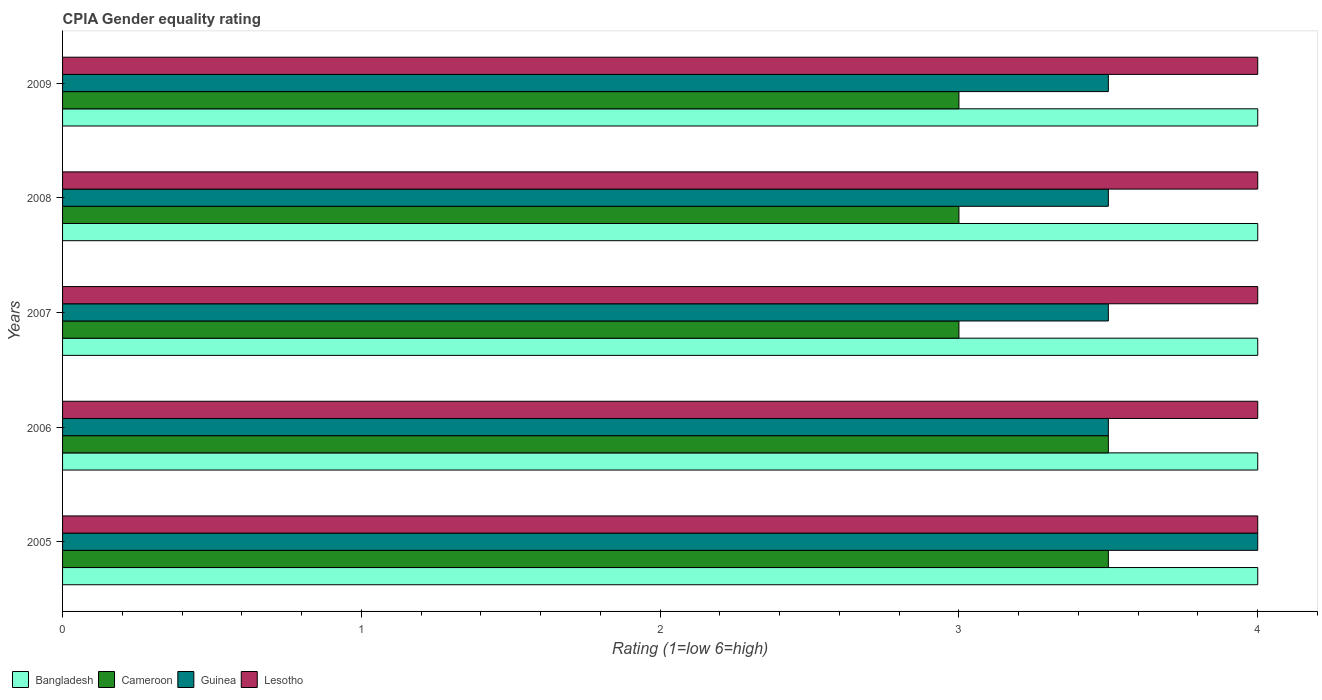Are the number of bars per tick equal to the number of legend labels?
Your answer should be very brief. Yes. Are the number of bars on each tick of the Y-axis equal?
Provide a short and direct response. Yes. How many bars are there on the 4th tick from the top?
Make the answer very short. 4. In how many cases, is the number of bars for a given year not equal to the number of legend labels?
Your response must be concise. 0. What is the CPIA rating in Lesotho in 2009?
Ensure brevity in your answer.  4. What is the total CPIA rating in Guinea in the graph?
Provide a succinct answer. 18. What is the difference between the CPIA rating in Bangladesh in 2006 and that in 2009?
Offer a very short reply. 0. What is the difference between the CPIA rating in Cameroon in 2008 and the CPIA rating in Bangladesh in 2007?
Your response must be concise. -1. What is the average CPIA rating in Bangladesh per year?
Your response must be concise. 4. In how many years, is the CPIA rating in Lesotho greater than 2 ?
Keep it short and to the point. 5. What is the ratio of the CPIA rating in Guinea in 2005 to that in 2006?
Give a very brief answer. 1.14. What is the difference between the highest and the second highest CPIA rating in Lesotho?
Provide a short and direct response. 0. What is the difference between the highest and the lowest CPIA rating in Bangladesh?
Give a very brief answer. 0. In how many years, is the CPIA rating in Bangladesh greater than the average CPIA rating in Bangladesh taken over all years?
Make the answer very short. 0. Is the sum of the CPIA rating in Cameroon in 2006 and 2009 greater than the maximum CPIA rating in Lesotho across all years?
Ensure brevity in your answer.  Yes. What does the 1st bar from the top in 2009 represents?
Keep it short and to the point. Lesotho. What does the 4th bar from the bottom in 2008 represents?
Make the answer very short. Lesotho. Are all the bars in the graph horizontal?
Make the answer very short. Yes. What is the difference between two consecutive major ticks on the X-axis?
Make the answer very short. 1. Are the values on the major ticks of X-axis written in scientific E-notation?
Your response must be concise. No. Does the graph contain any zero values?
Make the answer very short. No. Does the graph contain grids?
Offer a terse response. No. What is the title of the graph?
Offer a very short reply. CPIA Gender equality rating. What is the label or title of the X-axis?
Keep it short and to the point. Rating (1=low 6=high). What is the label or title of the Y-axis?
Keep it short and to the point. Years. What is the Rating (1=low 6=high) of Bangladesh in 2005?
Ensure brevity in your answer.  4. What is the Rating (1=low 6=high) in Guinea in 2005?
Your response must be concise. 4. What is the Rating (1=low 6=high) of Lesotho in 2005?
Your answer should be very brief. 4. What is the Rating (1=low 6=high) of Cameroon in 2006?
Make the answer very short. 3.5. What is the Rating (1=low 6=high) of Guinea in 2006?
Your response must be concise. 3.5. What is the Rating (1=low 6=high) of Lesotho in 2006?
Provide a short and direct response. 4. What is the Rating (1=low 6=high) of Guinea in 2007?
Provide a short and direct response. 3.5. What is the Rating (1=low 6=high) of Guinea in 2008?
Provide a short and direct response. 3.5. What is the Rating (1=low 6=high) of Bangladesh in 2009?
Keep it short and to the point. 4. What is the Rating (1=low 6=high) of Cameroon in 2009?
Make the answer very short. 3. Across all years, what is the maximum Rating (1=low 6=high) in Bangladesh?
Give a very brief answer. 4. Across all years, what is the maximum Rating (1=low 6=high) in Guinea?
Provide a succinct answer. 4. Across all years, what is the minimum Rating (1=low 6=high) in Guinea?
Give a very brief answer. 3.5. What is the total Rating (1=low 6=high) in Cameroon in the graph?
Your answer should be compact. 16. What is the total Rating (1=low 6=high) in Guinea in the graph?
Your answer should be very brief. 18. What is the difference between the Rating (1=low 6=high) of Bangladesh in 2005 and that in 2006?
Your response must be concise. 0. What is the difference between the Rating (1=low 6=high) of Guinea in 2005 and that in 2006?
Provide a succinct answer. 0.5. What is the difference between the Rating (1=low 6=high) of Lesotho in 2005 and that in 2006?
Offer a terse response. 0. What is the difference between the Rating (1=low 6=high) in Guinea in 2005 and that in 2007?
Give a very brief answer. 0.5. What is the difference between the Rating (1=low 6=high) in Bangladesh in 2005 and that in 2008?
Give a very brief answer. 0. What is the difference between the Rating (1=low 6=high) in Cameroon in 2005 and that in 2008?
Your answer should be very brief. 0.5. What is the difference between the Rating (1=low 6=high) of Guinea in 2005 and that in 2008?
Your answer should be very brief. 0.5. What is the difference between the Rating (1=low 6=high) in Lesotho in 2005 and that in 2008?
Offer a terse response. 0. What is the difference between the Rating (1=low 6=high) in Bangladesh in 2005 and that in 2009?
Offer a terse response. 0. What is the difference between the Rating (1=low 6=high) of Cameroon in 2005 and that in 2009?
Offer a very short reply. 0.5. What is the difference between the Rating (1=low 6=high) in Guinea in 2005 and that in 2009?
Keep it short and to the point. 0.5. What is the difference between the Rating (1=low 6=high) in Bangladesh in 2006 and that in 2007?
Make the answer very short. 0. What is the difference between the Rating (1=low 6=high) of Guinea in 2006 and that in 2007?
Your answer should be compact. 0. What is the difference between the Rating (1=low 6=high) in Lesotho in 2006 and that in 2008?
Ensure brevity in your answer.  0. What is the difference between the Rating (1=low 6=high) in Cameroon in 2006 and that in 2009?
Provide a short and direct response. 0.5. What is the difference between the Rating (1=low 6=high) in Guinea in 2006 and that in 2009?
Your answer should be compact. 0. What is the difference between the Rating (1=low 6=high) in Lesotho in 2007 and that in 2008?
Make the answer very short. 0. What is the difference between the Rating (1=low 6=high) in Lesotho in 2007 and that in 2009?
Provide a succinct answer. 0. What is the difference between the Rating (1=low 6=high) in Bangladesh in 2008 and that in 2009?
Keep it short and to the point. 0. What is the difference between the Rating (1=low 6=high) in Bangladesh in 2005 and the Rating (1=low 6=high) in Guinea in 2006?
Your answer should be compact. 0.5. What is the difference between the Rating (1=low 6=high) in Bangladesh in 2005 and the Rating (1=low 6=high) in Lesotho in 2006?
Offer a very short reply. 0. What is the difference between the Rating (1=low 6=high) of Cameroon in 2005 and the Rating (1=low 6=high) of Lesotho in 2006?
Keep it short and to the point. -0.5. What is the difference between the Rating (1=low 6=high) of Guinea in 2005 and the Rating (1=low 6=high) of Lesotho in 2006?
Your answer should be very brief. 0. What is the difference between the Rating (1=low 6=high) in Bangladesh in 2005 and the Rating (1=low 6=high) in Lesotho in 2007?
Provide a short and direct response. 0. What is the difference between the Rating (1=low 6=high) in Guinea in 2005 and the Rating (1=low 6=high) in Lesotho in 2007?
Keep it short and to the point. 0. What is the difference between the Rating (1=low 6=high) of Bangladesh in 2005 and the Rating (1=low 6=high) of Cameroon in 2008?
Keep it short and to the point. 1. What is the difference between the Rating (1=low 6=high) of Bangladesh in 2005 and the Rating (1=low 6=high) of Lesotho in 2008?
Your answer should be compact. 0. What is the difference between the Rating (1=low 6=high) of Cameroon in 2005 and the Rating (1=low 6=high) of Lesotho in 2008?
Offer a terse response. -0.5. What is the difference between the Rating (1=low 6=high) of Guinea in 2005 and the Rating (1=low 6=high) of Lesotho in 2008?
Ensure brevity in your answer.  0. What is the difference between the Rating (1=low 6=high) of Bangladesh in 2005 and the Rating (1=low 6=high) of Lesotho in 2009?
Your answer should be compact. 0. What is the difference between the Rating (1=low 6=high) of Cameroon in 2005 and the Rating (1=low 6=high) of Guinea in 2009?
Offer a terse response. 0. What is the difference between the Rating (1=low 6=high) in Bangladesh in 2006 and the Rating (1=low 6=high) in Cameroon in 2007?
Provide a short and direct response. 1. What is the difference between the Rating (1=low 6=high) of Cameroon in 2006 and the Rating (1=low 6=high) of Guinea in 2007?
Give a very brief answer. 0. What is the difference between the Rating (1=low 6=high) of Guinea in 2006 and the Rating (1=low 6=high) of Lesotho in 2007?
Ensure brevity in your answer.  -0.5. What is the difference between the Rating (1=low 6=high) of Bangladesh in 2006 and the Rating (1=low 6=high) of Guinea in 2008?
Your answer should be compact. 0.5. What is the difference between the Rating (1=low 6=high) in Bangladesh in 2006 and the Rating (1=low 6=high) in Lesotho in 2008?
Provide a short and direct response. 0. What is the difference between the Rating (1=low 6=high) of Cameroon in 2006 and the Rating (1=low 6=high) of Lesotho in 2008?
Ensure brevity in your answer.  -0.5. What is the difference between the Rating (1=low 6=high) in Bangladesh in 2006 and the Rating (1=low 6=high) in Guinea in 2009?
Offer a very short reply. 0.5. What is the difference between the Rating (1=low 6=high) in Cameroon in 2006 and the Rating (1=low 6=high) in Guinea in 2009?
Give a very brief answer. 0. What is the difference between the Rating (1=low 6=high) of Cameroon in 2006 and the Rating (1=low 6=high) of Lesotho in 2009?
Keep it short and to the point. -0.5. What is the difference between the Rating (1=low 6=high) in Bangladesh in 2007 and the Rating (1=low 6=high) in Guinea in 2008?
Keep it short and to the point. 0.5. What is the difference between the Rating (1=low 6=high) of Bangladesh in 2007 and the Rating (1=low 6=high) of Lesotho in 2008?
Your answer should be compact. 0. What is the difference between the Rating (1=low 6=high) of Guinea in 2007 and the Rating (1=low 6=high) of Lesotho in 2008?
Offer a very short reply. -0.5. What is the difference between the Rating (1=low 6=high) of Bangladesh in 2007 and the Rating (1=low 6=high) of Guinea in 2009?
Offer a terse response. 0.5. What is the difference between the Rating (1=low 6=high) of Guinea in 2007 and the Rating (1=low 6=high) of Lesotho in 2009?
Make the answer very short. -0.5. What is the difference between the Rating (1=low 6=high) of Guinea in 2008 and the Rating (1=low 6=high) of Lesotho in 2009?
Ensure brevity in your answer.  -0.5. What is the average Rating (1=low 6=high) in Cameroon per year?
Keep it short and to the point. 3.2. In the year 2005, what is the difference between the Rating (1=low 6=high) of Bangladesh and Rating (1=low 6=high) of Cameroon?
Provide a succinct answer. 0.5. In the year 2005, what is the difference between the Rating (1=low 6=high) of Cameroon and Rating (1=low 6=high) of Guinea?
Your answer should be very brief. -0.5. In the year 2006, what is the difference between the Rating (1=low 6=high) in Bangladesh and Rating (1=low 6=high) in Guinea?
Ensure brevity in your answer.  0.5. In the year 2006, what is the difference between the Rating (1=low 6=high) in Cameroon and Rating (1=low 6=high) in Lesotho?
Provide a succinct answer. -0.5. In the year 2007, what is the difference between the Rating (1=low 6=high) of Bangladesh and Rating (1=low 6=high) of Cameroon?
Give a very brief answer. 1. In the year 2007, what is the difference between the Rating (1=low 6=high) in Bangladesh and Rating (1=low 6=high) in Lesotho?
Ensure brevity in your answer.  0. In the year 2007, what is the difference between the Rating (1=low 6=high) in Cameroon and Rating (1=low 6=high) in Lesotho?
Offer a terse response. -1. In the year 2007, what is the difference between the Rating (1=low 6=high) of Guinea and Rating (1=low 6=high) of Lesotho?
Provide a short and direct response. -0.5. In the year 2008, what is the difference between the Rating (1=low 6=high) in Bangladesh and Rating (1=low 6=high) in Guinea?
Keep it short and to the point. 0.5. In the year 2008, what is the difference between the Rating (1=low 6=high) in Cameroon and Rating (1=low 6=high) in Guinea?
Give a very brief answer. -0.5. In the year 2008, what is the difference between the Rating (1=low 6=high) of Cameroon and Rating (1=low 6=high) of Lesotho?
Give a very brief answer. -1. In the year 2008, what is the difference between the Rating (1=low 6=high) in Guinea and Rating (1=low 6=high) in Lesotho?
Offer a terse response. -0.5. In the year 2009, what is the difference between the Rating (1=low 6=high) in Bangladesh and Rating (1=low 6=high) in Cameroon?
Keep it short and to the point. 1. In the year 2009, what is the difference between the Rating (1=low 6=high) of Cameroon and Rating (1=low 6=high) of Lesotho?
Offer a very short reply. -1. In the year 2009, what is the difference between the Rating (1=low 6=high) in Guinea and Rating (1=low 6=high) in Lesotho?
Give a very brief answer. -0.5. What is the ratio of the Rating (1=low 6=high) of Bangladesh in 2005 to that in 2006?
Provide a short and direct response. 1. What is the ratio of the Rating (1=low 6=high) of Guinea in 2005 to that in 2006?
Provide a short and direct response. 1.14. What is the ratio of the Rating (1=low 6=high) of Lesotho in 2005 to that in 2006?
Your response must be concise. 1. What is the ratio of the Rating (1=low 6=high) of Bangladesh in 2005 to that in 2007?
Give a very brief answer. 1. What is the ratio of the Rating (1=low 6=high) in Lesotho in 2005 to that in 2007?
Keep it short and to the point. 1. What is the ratio of the Rating (1=low 6=high) of Guinea in 2005 to that in 2008?
Your answer should be very brief. 1.14. What is the ratio of the Rating (1=low 6=high) in Lesotho in 2005 to that in 2008?
Ensure brevity in your answer.  1. What is the ratio of the Rating (1=low 6=high) in Bangladesh in 2005 to that in 2009?
Offer a very short reply. 1. What is the ratio of the Rating (1=low 6=high) in Cameroon in 2005 to that in 2009?
Keep it short and to the point. 1.17. What is the ratio of the Rating (1=low 6=high) in Cameroon in 2006 to that in 2007?
Your response must be concise. 1.17. What is the ratio of the Rating (1=low 6=high) of Lesotho in 2006 to that in 2007?
Keep it short and to the point. 1. What is the ratio of the Rating (1=low 6=high) of Bangladesh in 2006 to that in 2008?
Provide a short and direct response. 1. What is the ratio of the Rating (1=low 6=high) in Cameroon in 2006 to that in 2009?
Give a very brief answer. 1.17. What is the ratio of the Rating (1=low 6=high) in Bangladesh in 2007 to that in 2008?
Give a very brief answer. 1. What is the ratio of the Rating (1=low 6=high) of Lesotho in 2007 to that in 2008?
Make the answer very short. 1. What is the ratio of the Rating (1=low 6=high) in Bangladesh in 2007 to that in 2009?
Your response must be concise. 1. What is the ratio of the Rating (1=low 6=high) of Guinea in 2007 to that in 2009?
Offer a very short reply. 1. What is the ratio of the Rating (1=low 6=high) in Bangladesh in 2008 to that in 2009?
Your response must be concise. 1. What is the ratio of the Rating (1=low 6=high) of Cameroon in 2008 to that in 2009?
Offer a very short reply. 1. What is the difference between the highest and the second highest Rating (1=low 6=high) of Bangladesh?
Offer a terse response. 0. What is the difference between the highest and the second highest Rating (1=low 6=high) in Cameroon?
Offer a terse response. 0. What is the difference between the highest and the lowest Rating (1=low 6=high) in Bangladesh?
Your answer should be very brief. 0. What is the difference between the highest and the lowest Rating (1=low 6=high) in Cameroon?
Your answer should be compact. 0.5. What is the difference between the highest and the lowest Rating (1=low 6=high) in Guinea?
Give a very brief answer. 0.5. What is the difference between the highest and the lowest Rating (1=low 6=high) of Lesotho?
Offer a terse response. 0. 